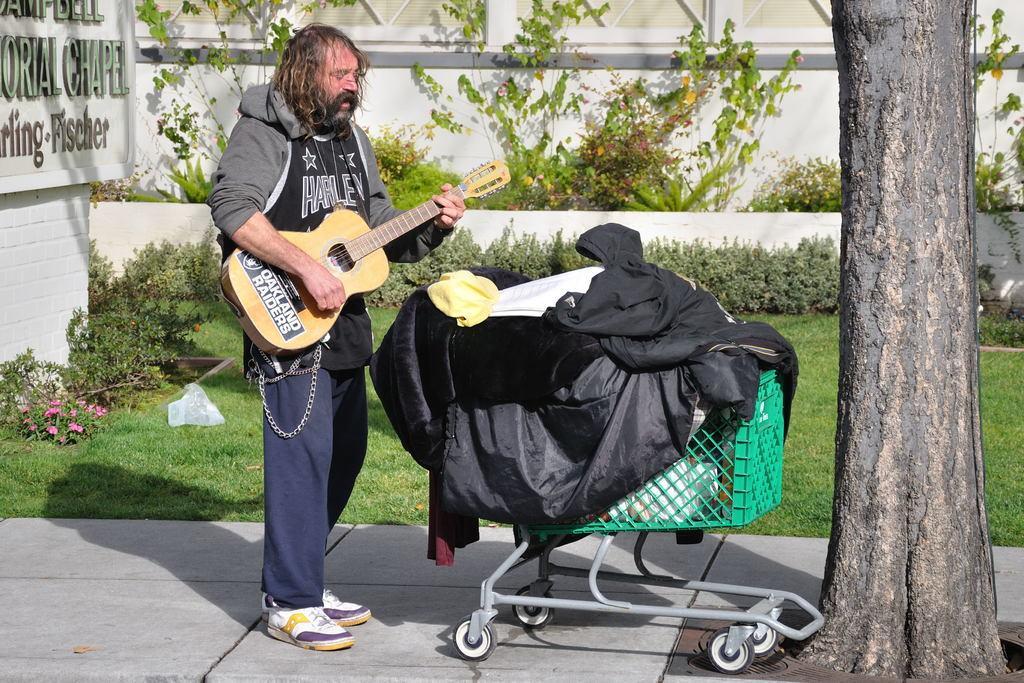In one or two sentences, can you explain what this image depicts? This person is holding a guitar. In-front of this person there is a cart, in this chart there are clothes and things. This are plants and grass. A board is attached to this wall. 